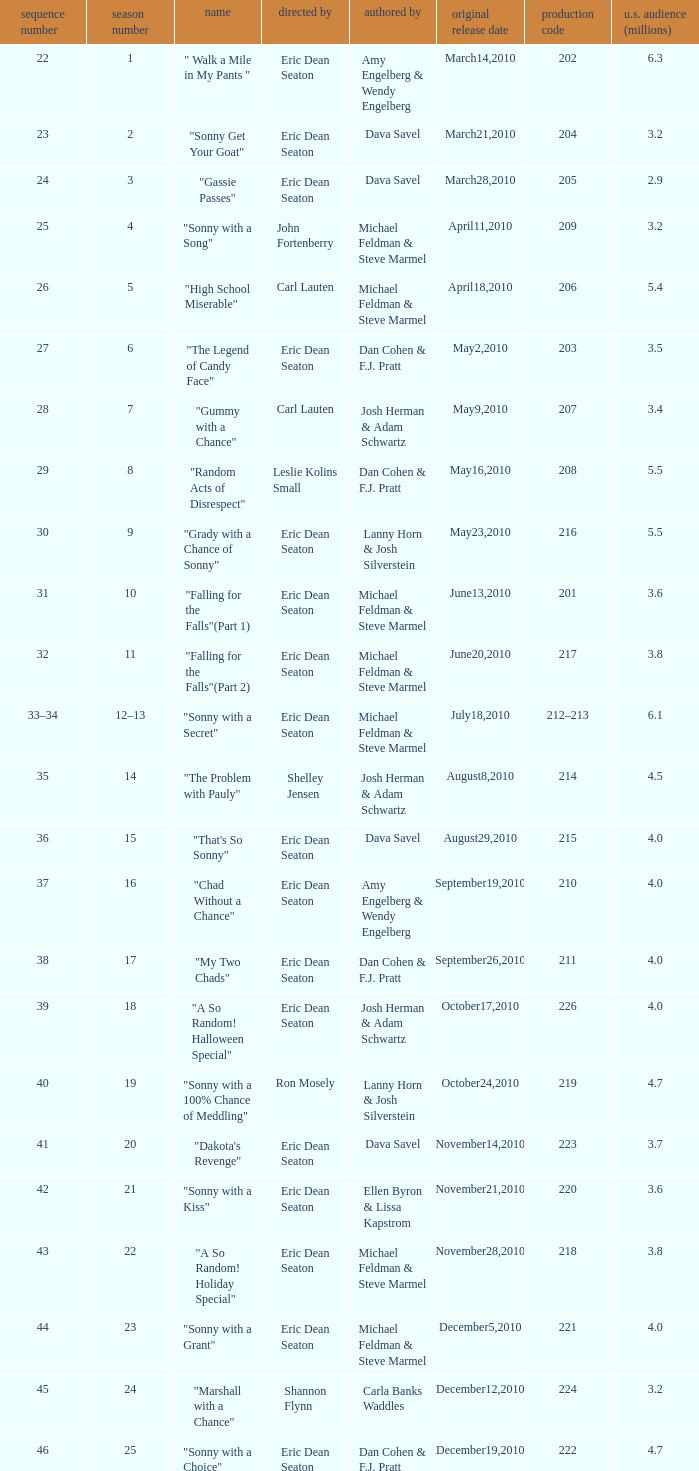Who directed the episode that 6.3 million u.s. viewers saw? Eric Dean Seaton. 